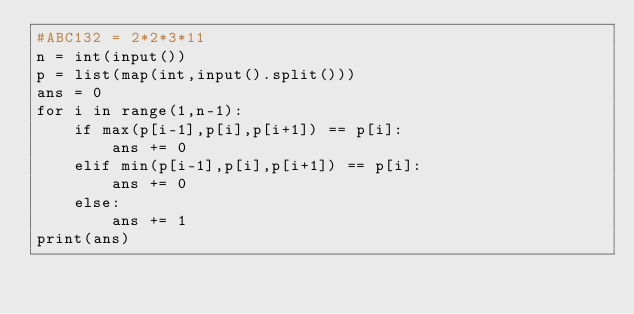<code> <loc_0><loc_0><loc_500><loc_500><_Python_>#ABC132 = 2*2*3*11
n = int(input())
p = list(map(int,input().split()))
ans = 0
for i in range(1,n-1):
    if max(p[i-1],p[i],p[i+1]) == p[i]:
        ans += 0
    elif min(p[i-1],p[i],p[i+1]) == p[i]:
        ans += 0
    else:
        ans += 1
print(ans)</code> 